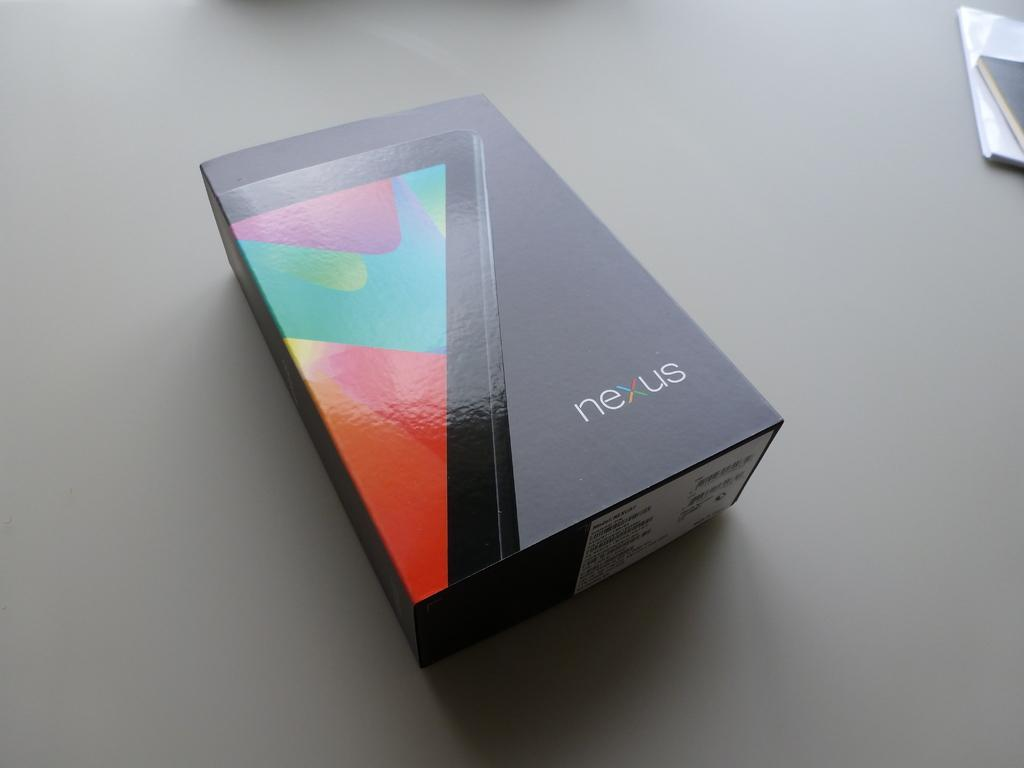Provide a one-sentence caption for the provided image. Black box that says NEXUS on it that shows a phone. 